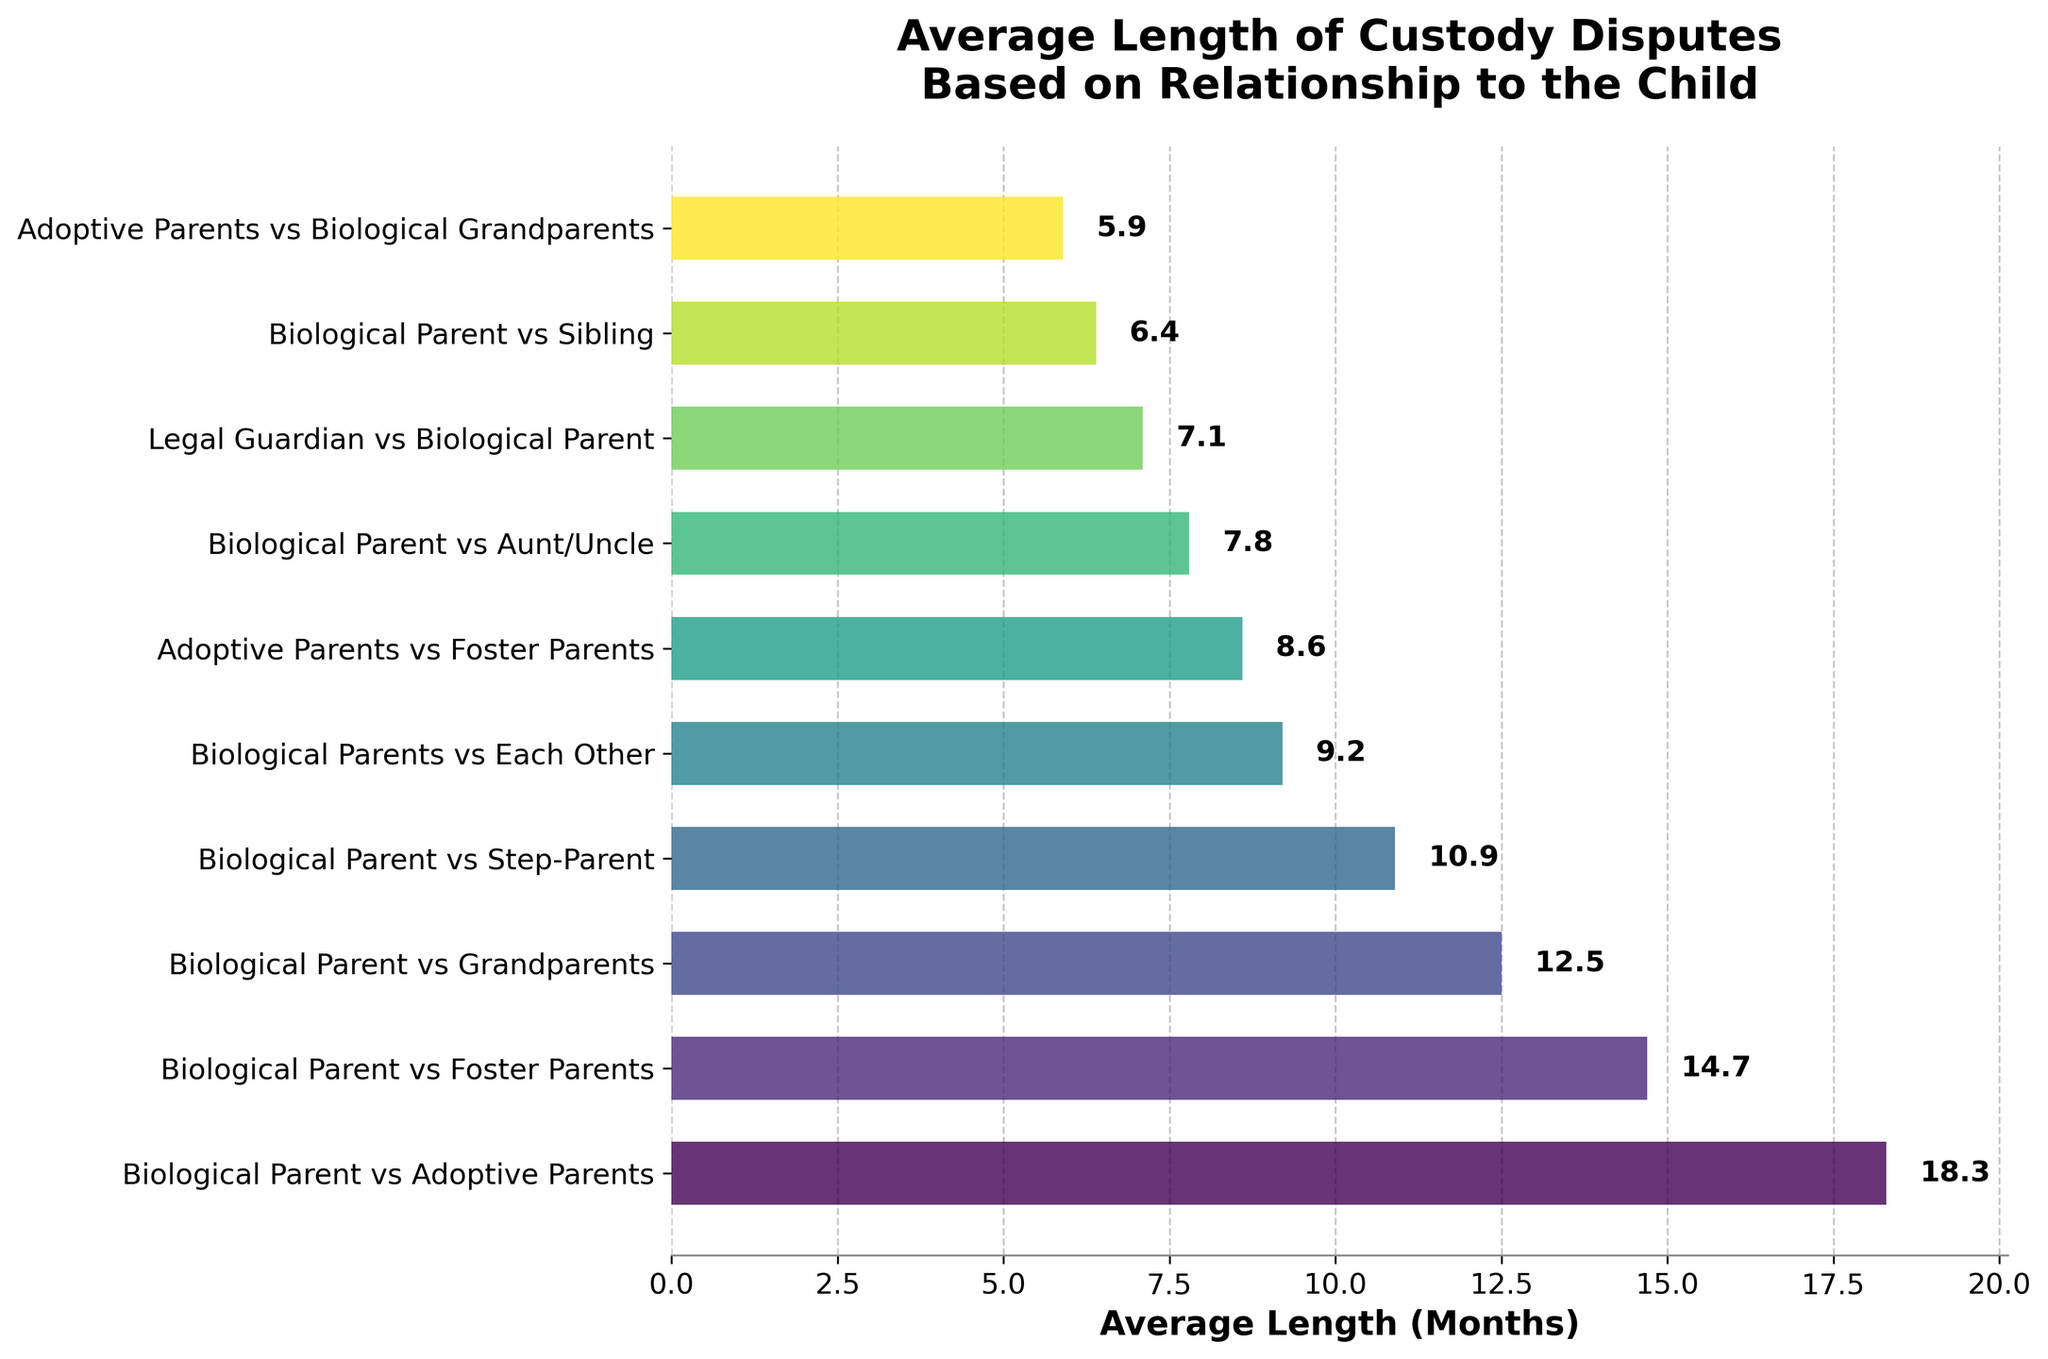What's the longest average length of custody disputes? The bar representing "Biological Parent vs Adoptive Parents" is the longest at 18.3 months.
Answer: 18.3 months Which dispute has the shortest average length? The smallest bar in the figure corresponds to "Adoptive Parents vs Biological Grandparents" with a length of 5.9 months.
Answer: 5.9 months How does the length of disputes between biological parents and adoptive parents compare to disputes between biological parents and foster parents? The average length of disputes between biological parents and adoptive parents is 18.3 months, while it is 14.7 months for disputes between biological parents and foster parents. 18.3 is greater than 14.7.
Answer: 18.3 months is longer Among the disputes, which has a longer duration: biological parents vs. step-parents or biological parents vs. grandparents? The average duration for biological parents vs. step-parents is 10.9 months, whereas for biological parents vs. grandparents it is 12.5 months. 12.5 is greater than 10.9.
Answer: Biological parents vs. grandparents What is the average length of disputes between biological parents vs. each other and legal guardian vs. biological parent? The average length for biological parents vs. each other is 9.2 months and for legal guardian vs. biological parent is 7.1 months. The average is (9.2 + 7.1) / 2.
Answer: 8.15 months Are disputes involving biological parents vs. siblings longer than disputes involving biological parents vs. aunt/uncle? The average length for biological parents vs. siblings is 6.4 months, while for biological parents vs. aunt/uncle it is 7.8 months. 6.4 is less than 7.8.
Answer: No What is the combined average length of disputes between biological parent vs foster parents and biological parent vs adoptive parents? The average length for biological parent vs foster parents is 14.7 months and for biological parent vs adoptive parents is 18.3 months. Their combined length is 14.7 + 18.3.
Answer: 33 months Which bars have lengths less than 8 months? The bars for disputes between "Biological Parent vs Sibling" (6.4 months), "Adoptive Parents vs Biological Grandparents" (5.9 months), and "Legal Guardian vs Biological Parent" (7.1 months) are all less than 8 months.
Answer: Biological Parent vs Sibling, Adoptive Parents vs Biological Grandparents, Legal Guardian vs Biological Parent Do disputes involving grandparents (both biological and adoptive) have shorter or longer durations compared to disputes involving step-parents? Disputes involving biological grandparents have an average length of 12.5 months and adoptive grandparents 5.9 months. Disputes involving step-parents have an average length of 10.9 months. Combined grandparents' average (9.2) is shorter than step-parents (10.9).
Answer: Shorter 